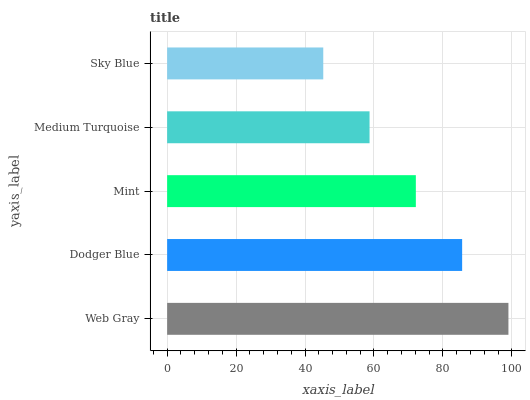Is Sky Blue the minimum?
Answer yes or no. Yes. Is Web Gray the maximum?
Answer yes or no. Yes. Is Dodger Blue the minimum?
Answer yes or no. No. Is Dodger Blue the maximum?
Answer yes or no. No. Is Web Gray greater than Dodger Blue?
Answer yes or no. Yes. Is Dodger Blue less than Web Gray?
Answer yes or no. Yes. Is Dodger Blue greater than Web Gray?
Answer yes or no. No. Is Web Gray less than Dodger Blue?
Answer yes or no. No. Is Mint the high median?
Answer yes or no. Yes. Is Mint the low median?
Answer yes or no. Yes. Is Dodger Blue the high median?
Answer yes or no. No. Is Web Gray the low median?
Answer yes or no. No. 